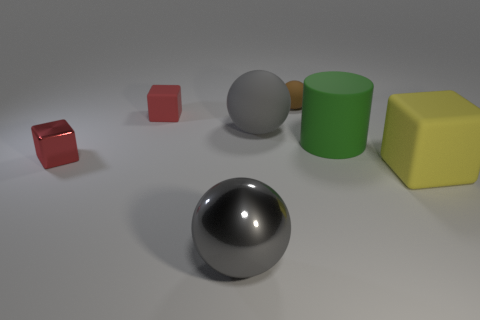Subtract all small matte spheres. How many spheres are left? 2 Subtract all red cubes. How many were subtracted if there are1red cubes left? 1 Subtract all yellow cubes. How many cubes are left? 2 Subtract 1 spheres. How many spheres are left? 2 Subtract all cyan balls. Subtract all gray blocks. How many balls are left? 3 Subtract all blue spheres. How many purple blocks are left? 0 Subtract all yellow matte things. Subtract all small red matte blocks. How many objects are left? 5 Add 1 tiny brown matte things. How many tiny brown matte things are left? 2 Add 6 big gray rubber balls. How many big gray rubber balls exist? 7 Add 2 green matte cylinders. How many objects exist? 9 